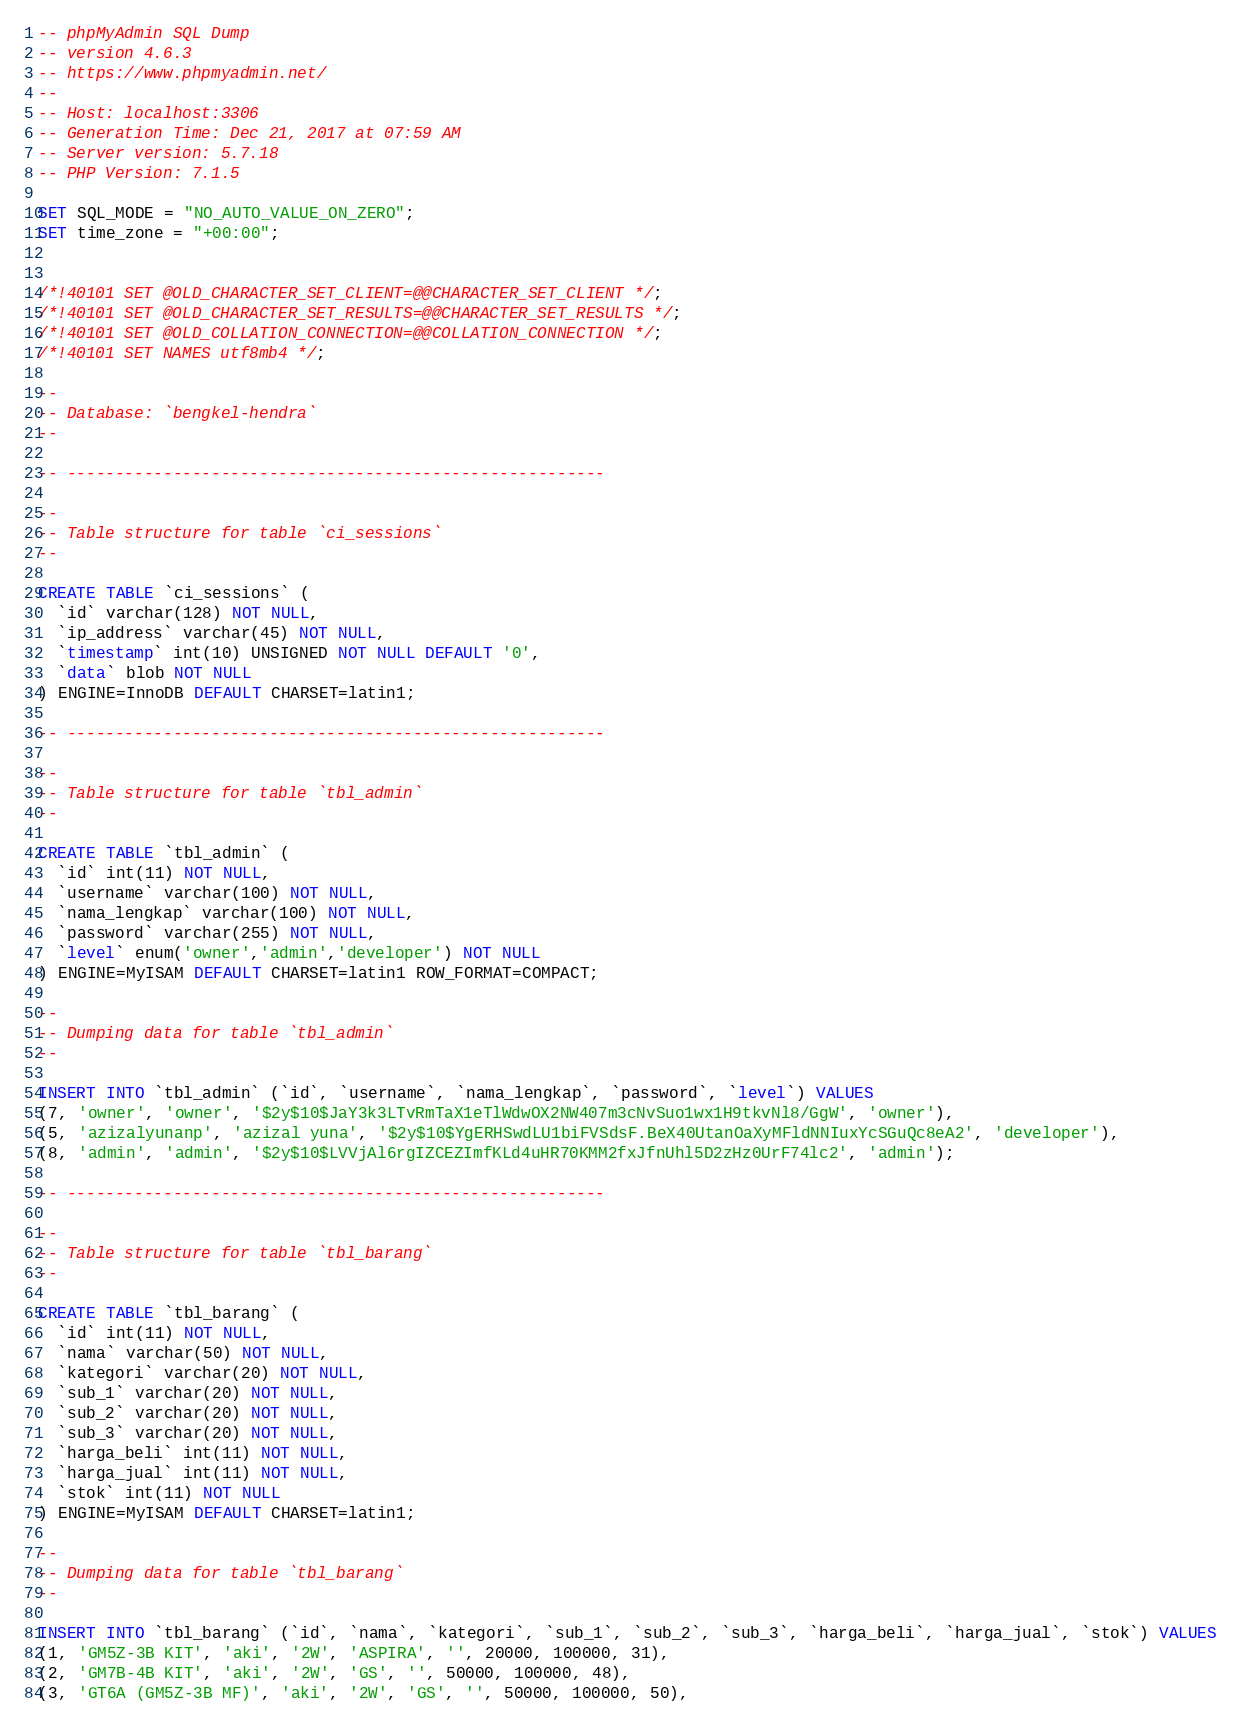Convert code to text. <code><loc_0><loc_0><loc_500><loc_500><_SQL_>-- phpMyAdmin SQL Dump
-- version 4.6.3
-- https://www.phpmyadmin.net/
--
-- Host: localhost:3306
-- Generation Time: Dec 21, 2017 at 07:59 AM
-- Server version: 5.7.18
-- PHP Version: 7.1.5

SET SQL_MODE = "NO_AUTO_VALUE_ON_ZERO";
SET time_zone = "+00:00";


/*!40101 SET @OLD_CHARACTER_SET_CLIENT=@@CHARACTER_SET_CLIENT */;
/*!40101 SET @OLD_CHARACTER_SET_RESULTS=@@CHARACTER_SET_RESULTS */;
/*!40101 SET @OLD_COLLATION_CONNECTION=@@COLLATION_CONNECTION */;
/*!40101 SET NAMES utf8mb4 */;

--
-- Database: `bengkel-hendra`
--

-- --------------------------------------------------------

--
-- Table structure for table `ci_sessions`
--

CREATE TABLE `ci_sessions` (
  `id` varchar(128) NOT NULL,
  `ip_address` varchar(45) NOT NULL,
  `timestamp` int(10) UNSIGNED NOT NULL DEFAULT '0',
  `data` blob NOT NULL
) ENGINE=InnoDB DEFAULT CHARSET=latin1;

-- --------------------------------------------------------

--
-- Table structure for table `tbl_admin`
--

CREATE TABLE `tbl_admin` (
  `id` int(11) NOT NULL,
  `username` varchar(100) NOT NULL,
  `nama_lengkap` varchar(100) NOT NULL,
  `password` varchar(255) NOT NULL,
  `level` enum('owner','admin','developer') NOT NULL
) ENGINE=MyISAM DEFAULT CHARSET=latin1 ROW_FORMAT=COMPACT;

--
-- Dumping data for table `tbl_admin`
--

INSERT INTO `tbl_admin` (`id`, `username`, `nama_lengkap`, `password`, `level`) VALUES
(7, 'owner', 'owner', '$2y$10$JaY3k3LTvRmTaX1eTlWdwOX2NW407m3cNvSuo1wx1H9tkvNl8/GgW', 'owner'),
(5, 'azizalyunanp', 'azizal yuna', '$2y$10$YgERHSwdLU1biFVSdsF.BeX40UtanOaXyMFldNNIuxYcSGuQc8eA2', 'developer'),
(8, 'admin', 'admin', '$2y$10$LVVjAl6rgIZCEZImfKLd4uHR70KMM2fxJfnUhl5D2zHz0UrF74lc2', 'admin');

-- --------------------------------------------------------

--
-- Table structure for table `tbl_barang`
--

CREATE TABLE `tbl_barang` (
  `id` int(11) NOT NULL,
  `nama` varchar(50) NOT NULL,
  `kategori` varchar(20) NOT NULL,
  `sub_1` varchar(20) NOT NULL,
  `sub_2` varchar(20) NOT NULL,
  `sub_3` varchar(20) NOT NULL,
  `harga_beli` int(11) NOT NULL,
  `harga_jual` int(11) NOT NULL,
  `stok` int(11) NOT NULL
) ENGINE=MyISAM DEFAULT CHARSET=latin1;

--
-- Dumping data for table `tbl_barang`
--

INSERT INTO `tbl_barang` (`id`, `nama`, `kategori`, `sub_1`, `sub_2`, `sub_3`, `harga_beli`, `harga_jual`, `stok`) VALUES
(1, 'GM5Z-3B KIT', 'aki', '2W', 'ASPIRA', '', 20000, 100000, 31),
(2, 'GM7B-4B KIT', 'aki', '2W', 'GS', '', 50000, 100000, 48),
(3, 'GT6A (GM5Z-3B MF)', 'aki', '2W', 'GS', '', 50000, 100000, 50),</code> 